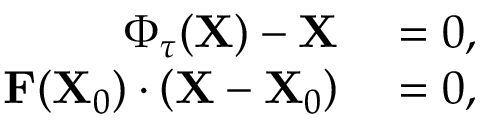Convert formula to latex. <formula><loc_0><loc_0><loc_500><loc_500>\begin{array} { r l } { \Phi _ { \tau } ( X ) - X } & = 0 , } \\ { F ( X _ { 0 } ) \cdot \left ( X - X _ { 0 } \right ) } & = 0 , } \end{array}</formula> 